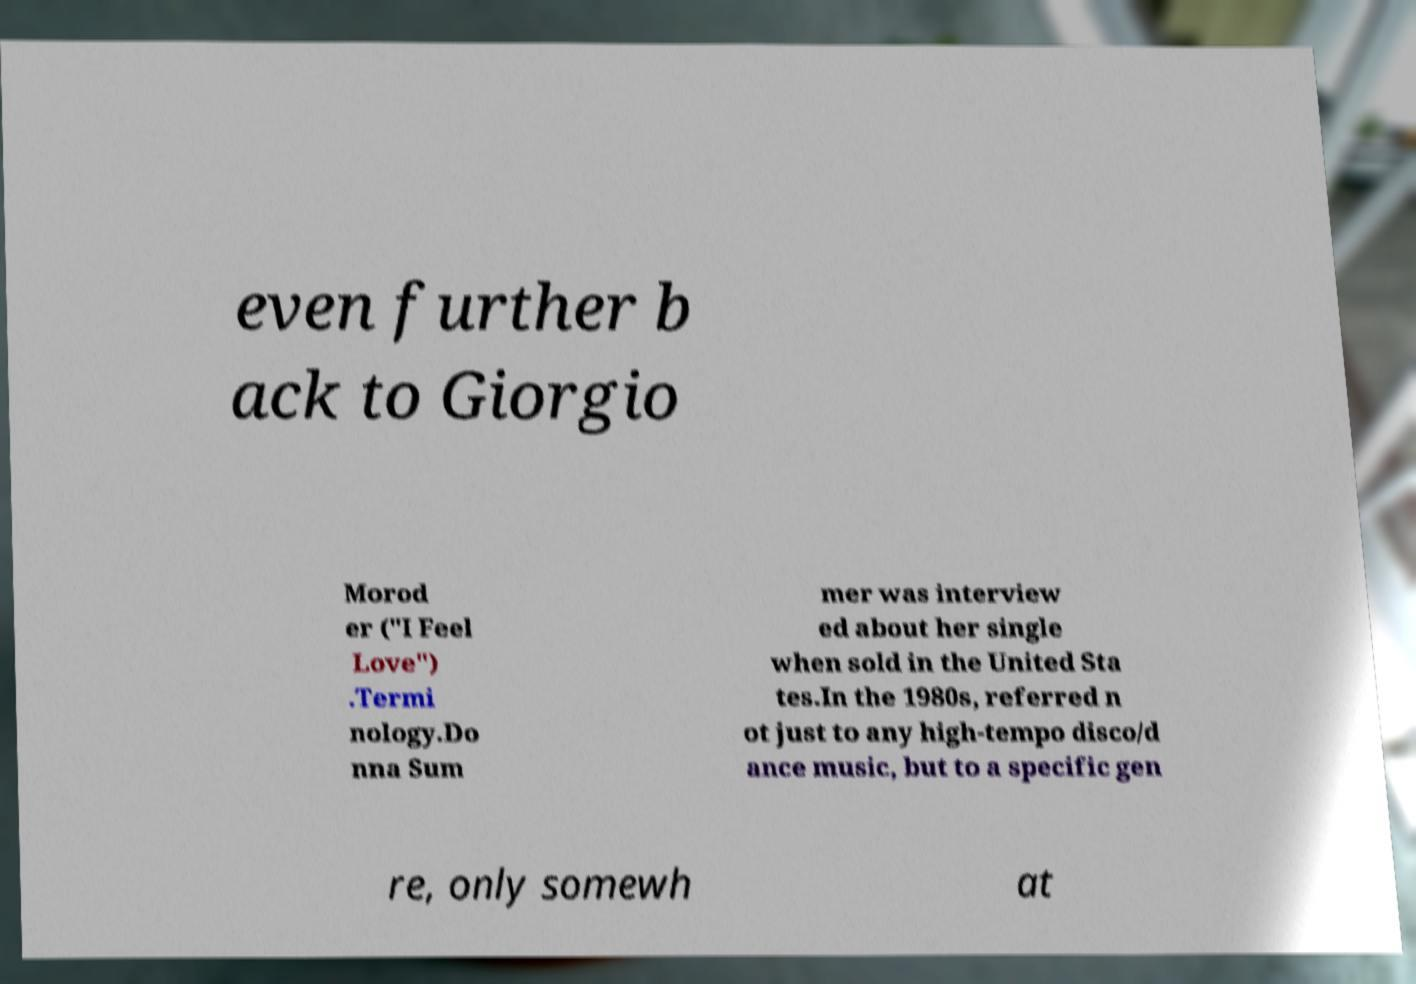There's text embedded in this image that I need extracted. Can you transcribe it verbatim? even further b ack to Giorgio Morod er ("I Feel Love") .Termi nology.Do nna Sum mer was interview ed about her single when sold in the United Sta tes.In the 1980s, referred n ot just to any high-tempo disco/d ance music, but to a specific gen re, only somewh at 